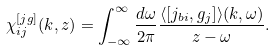Convert formula to latex. <formula><loc_0><loc_0><loc_500><loc_500>\chi _ { i j } ^ { [ j g ] } ( { k } , z ) = \int _ { - \infty } ^ { \infty } \frac { d \omega } { 2 \pi } \frac { \langle [ j _ { b i } , g _ { j } ] \rangle ( { k } , \omega ) } { z - \omega } .</formula> 